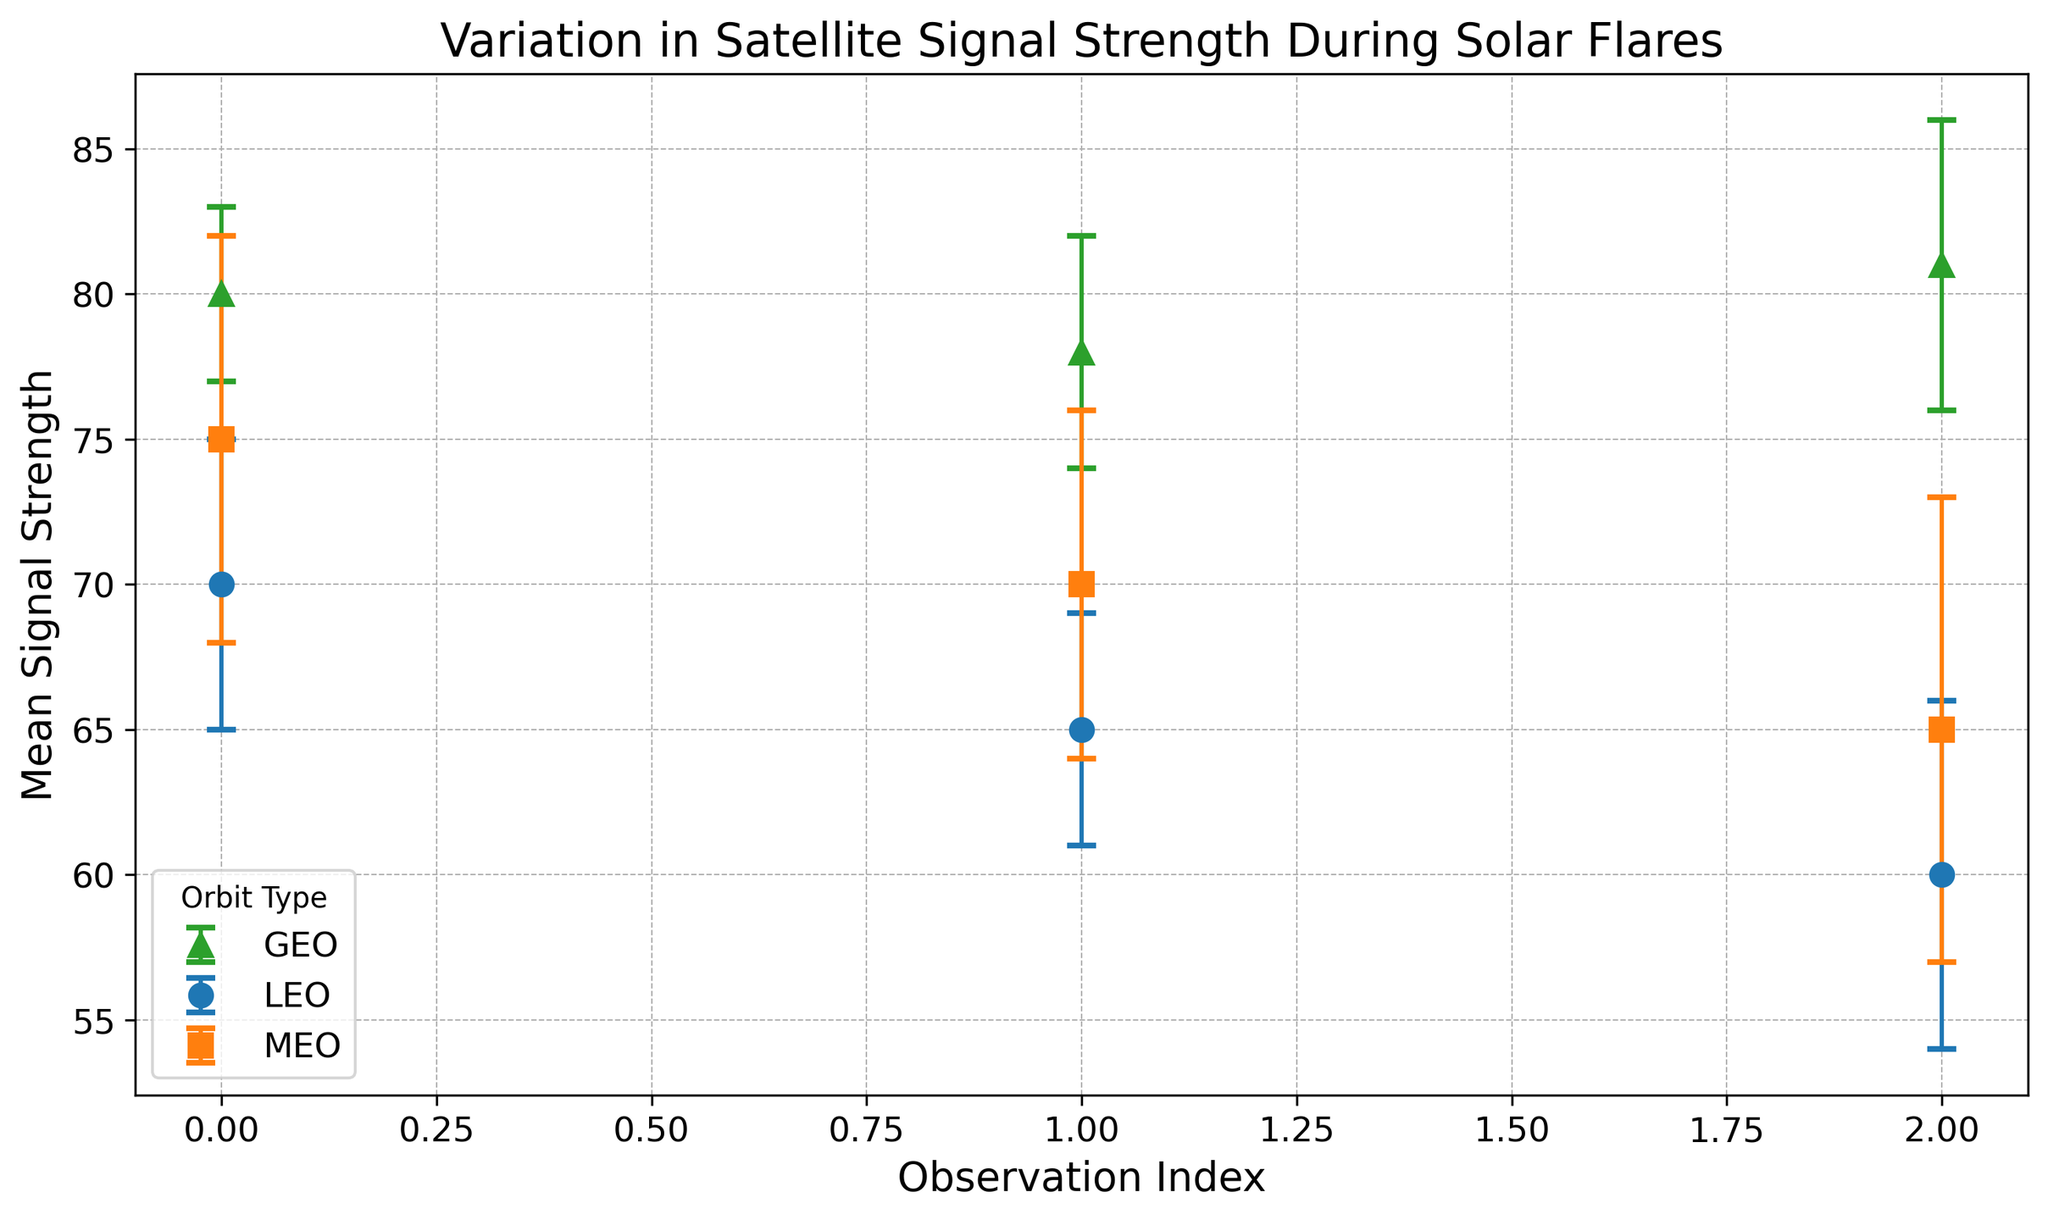What is the mean signal strength for the MEO orbit at the second observation index? Look at the MEO Orbit, which uses square markers, and find the second observation index. The mean signal strength is 70.
Answer: 70 Which orbit type has the smallest variation in signal strength during the observations? To determine the smallest variation, compare the lengths of the error bars for each orbit. GEO orbit has the smallest error bars indicating the least variation.
Answer: GEO What is the difference in mean signal strength between the highest and lowest observed values in the LEO orbit? For LEO, the highest mean signal strength is 70, and the lowest is 60. The difference is 70 - 60.
Answer: 10 How does the mean signal strength of the first observation in LEO compare with the last observation in GEO? The first observation in LEO has a mean signal strength of 70. The last observation in GEO has a mean signal strength of 81. GEO's value is higher than LEO's.
Answer: GEO's is higher Which orbit type shows the highest mean signal strength across all observations? By observing the markers for each orbit, GEO consistently shows the highest mean values with the highest being 81.
Answer: GEO What is the average mean signal strength of the MEO orbit across all observations? Sum the mean signal strengths of MEO (75 + 70 + 65) and divide by the number of observations (3). The calculation is (75 + 70 + 65) / 3.
Answer: 70 Compare the standard deviation for the highest mean signal strength observed in LEO and GEO. Which is higher? Find the highest mean signal strength in LEO (70) and GEO (81) and compare their error bars (standard deviation). LEO has a standard deviation of 5, and GEO’s is 5. They are the same.
Answer: Same What's the total sum of mean signal strengths for all observations in the GEO orbit? Sum the mean signal strengths in the GEO orbit (80 + 78 + 81). The total sum is 80 + 78 + 81.
Answer: 239 What is the most common range of standard deviation across all observations? Observe the error bars for each orbit and find the most frequent range. The error bars typically range from 4 to 6.
Answer: 4-6 